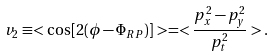Convert formula to latex. <formula><loc_0><loc_0><loc_500><loc_500>v _ { 2 } \equiv < \cos [ 2 ( \phi - \Phi _ { R P } ) ] > = < \frac { p _ { x } ^ { 2 } - p _ { y } ^ { 2 } } { p _ { t } ^ { 2 } } > .</formula> 